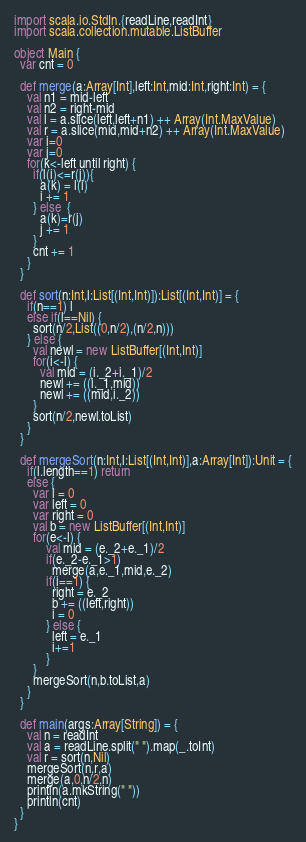Convert code to text. <code><loc_0><loc_0><loc_500><loc_500><_Scala_>import scala.io.StdIn.{readLine,readInt}
import scala.collection.mutable.ListBuffer

object Main {
  var cnt = 0

  def merge(a:Array[Int],left:Int,mid:Int,right:Int) = {
    val n1 = mid-left
    val n2 = right-mid
    val l = a.slice(left,left+n1) ++ Array(Int.MaxValue)
    val r = a.slice(mid,mid+n2) ++ Array(Int.MaxValue)
    var i=0
    var j=0
    for(k<-left until right) {
      if(l(i)<=r(j)){
        a(k) = l(i)
        i += 1
      } else  {
        a(k)=r(j)
        j += 1
      }
      cnt += 1
    }
  }

  def sort(n:Int,l:List[(Int,Int)]):List[(Int,Int)] = {
    if(n==1) l
    else if(l==Nil) {
      sort(n/2,List((0,n/2),(n/2,n)))
    } else {
      val newl = new ListBuffer[(Int,Int)]
      for(i<-l) {
        val mid = (i._2+i._1)/2
        newl += ((i._1,mid))
        newl += ((mid,i._2))
      }
      sort(n/2,newl.toList)
    }
  }

  def mergeSort(n:Int,l:List[(Int,Int)],a:Array[Int]):Unit = {
    if(l.length==1) return
    else {
      var i = 0
      var left = 0
      var right = 0
      val b = new ListBuffer[(Int,Int)]
      for(e<-l) {
          val mid = (e._2+e._1)/2
          if(e._2-e._1>1)
            merge(a,e._1,mid,e._2)
          if(i==1) {
            right = e._2
            b += ((left,right))
            i = 0
          } else {
            left = e._1
            i+=1
          }
      }
      mergeSort(n,b.toList,a)
    }
  }

  def main(args:Array[String]) = {
    val n = readInt
    val a = readLine.split(" ").map(_.toInt)
    val r = sort(n,Nil)
    mergeSort(n,r,a)
    merge(a,0,n/2,n)
    println(a.mkString(" "))
    println(cnt)
  }
}</code> 